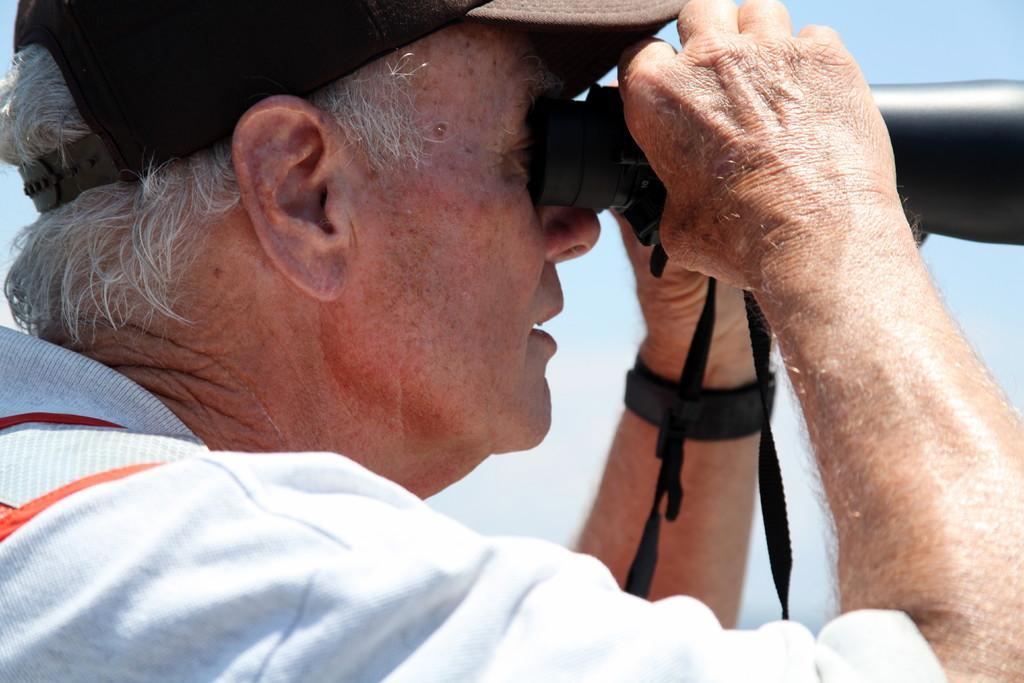In one or two sentences, can you explain what this image depicts? In the foreground of this picture, there is a man in white T shirt holding a binoculars telescope in his hand. In the background, there is the sky. 